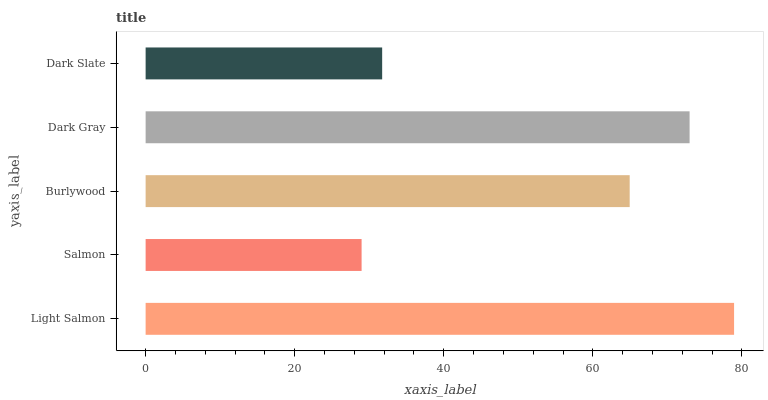Is Salmon the minimum?
Answer yes or no. Yes. Is Light Salmon the maximum?
Answer yes or no. Yes. Is Burlywood the minimum?
Answer yes or no. No. Is Burlywood the maximum?
Answer yes or no. No. Is Burlywood greater than Salmon?
Answer yes or no. Yes. Is Salmon less than Burlywood?
Answer yes or no. Yes. Is Salmon greater than Burlywood?
Answer yes or no. No. Is Burlywood less than Salmon?
Answer yes or no. No. Is Burlywood the high median?
Answer yes or no. Yes. Is Burlywood the low median?
Answer yes or no. Yes. Is Light Salmon the high median?
Answer yes or no. No. Is Dark Gray the low median?
Answer yes or no. No. 